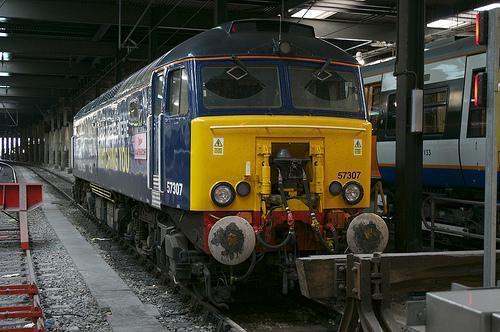How many trains do you see?
Give a very brief answer. 2. 